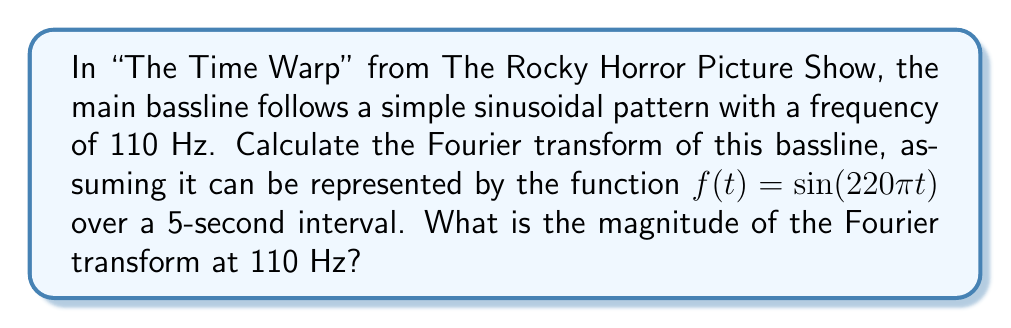Give your solution to this math problem. Let's approach this step-by-step:

1) The Fourier transform of a function $f(t)$ is given by:

   $$F(\omega) = \int_{-\infty}^{\infty} f(t) e^{-i\omega t} dt$$

2) In our case, $f(t) = \sin(220\pi t)$ and we're interested in a 5-second interval, so our integral becomes:

   $$F(\omega) = \int_{0}^{5} \sin(220\pi t) e^{-i\omega t} dt$$

3) We're asked about the magnitude at 110 Hz, which corresponds to $\omega = 2\pi(110) = 220\pi$ rad/s.

4) Substituting this into our integral:

   $$F(220\pi) = \int_{0}^{5} \sin(220\pi t) e^{-i220\pi t} dt$$

5) Using Euler's formula, $e^{-i220\pi t} = \cos(220\pi t) - i\sin(220\pi t)$, we get:

   $$F(220\pi) = \int_{0}^{5} \sin(220\pi t) [\cos(220\pi t) - i\sin(220\pi t)] dt$$

6) Expanding this:

   $$F(220\pi) = \int_{0}^{5} [\sin(220\pi t)\cos(220\pi t) - i\sin^2(220\pi t)] dt$$

7) The first term integrates to zero over a complete cycle (which occurs many times in 5 seconds). For the second term:

   $$F(220\pi) = -i\int_{0}^{5} \sin^2(220\pi t) dt$$

8) Using the identity $\sin^2(x) = \frac{1}{2}(1 - \cos(2x))$:

   $$F(220\pi) = -i\int_{0}^{5} \frac{1}{2}(1 - \cos(440\pi t)) dt$$

9) Integrating:

   $$F(220\pi) = -i[\frac{1}{2}t - \frac{1}{880\pi}\sin(440\pi t)]_0^5 = -\frac{5i}{2}$$

10) The magnitude is the absolute value of this complex number:

    $$|F(220\pi)| = |\frac{5i}{2}| = \frac{5}{2} = 2.5$$
Answer: 2.5 